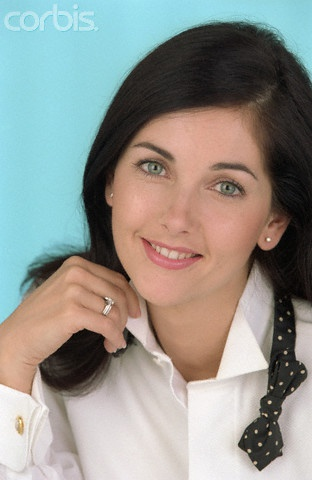Describe the objects in this image and their specific colors. I can see people in lightblue, black, lightgray, and tan tones, tie in lightblue, black, gray, and darkgray tones, and tie in lightblue, black, and gray tones in this image. 